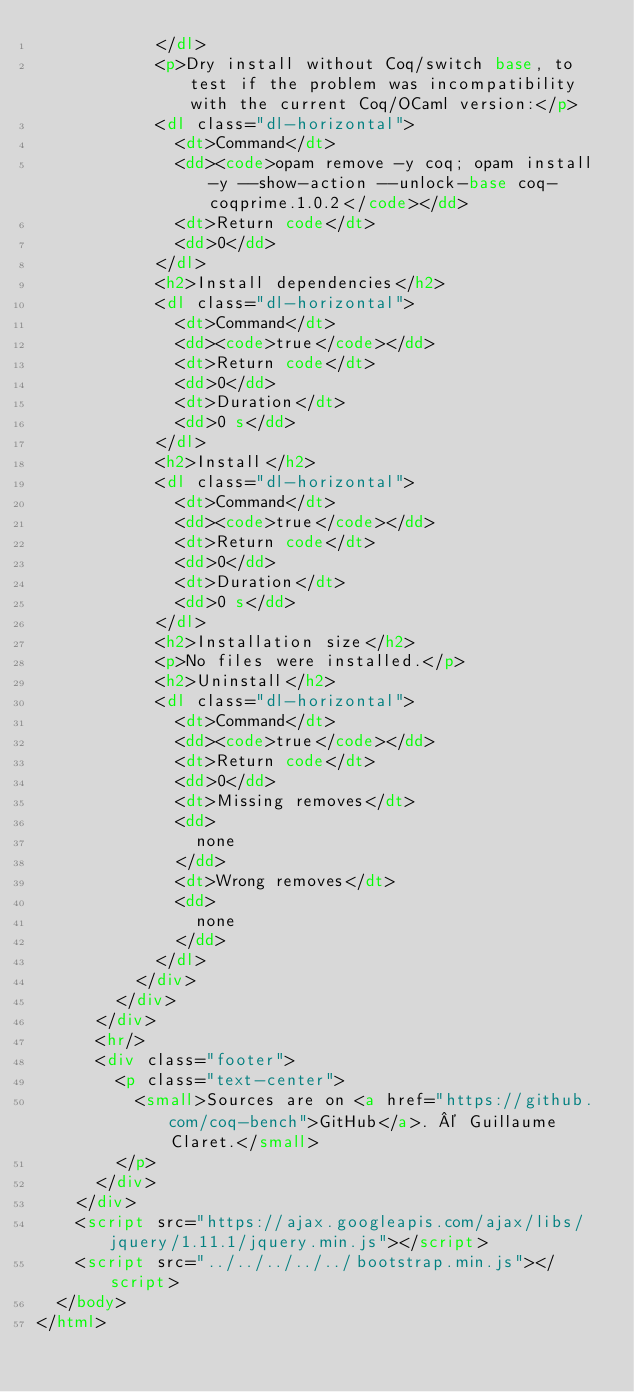Convert code to text. <code><loc_0><loc_0><loc_500><loc_500><_HTML_>            </dl>
            <p>Dry install without Coq/switch base, to test if the problem was incompatibility with the current Coq/OCaml version:</p>
            <dl class="dl-horizontal">
              <dt>Command</dt>
              <dd><code>opam remove -y coq; opam install -y --show-action --unlock-base coq-coqprime.1.0.2</code></dd>
              <dt>Return code</dt>
              <dd>0</dd>
            </dl>
            <h2>Install dependencies</h2>
            <dl class="dl-horizontal">
              <dt>Command</dt>
              <dd><code>true</code></dd>
              <dt>Return code</dt>
              <dd>0</dd>
              <dt>Duration</dt>
              <dd>0 s</dd>
            </dl>
            <h2>Install</h2>
            <dl class="dl-horizontal">
              <dt>Command</dt>
              <dd><code>true</code></dd>
              <dt>Return code</dt>
              <dd>0</dd>
              <dt>Duration</dt>
              <dd>0 s</dd>
            </dl>
            <h2>Installation size</h2>
            <p>No files were installed.</p>
            <h2>Uninstall</h2>
            <dl class="dl-horizontal">
              <dt>Command</dt>
              <dd><code>true</code></dd>
              <dt>Return code</dt>
              <dd>0</dd>
              <dt>Missing removes</dt>
              <dd>
                none
              </dd>
              <dt>Wrong removes</dt>
              <dd>
                none
              </dd>
            </dl>
          </div>
        </div>
      </div>
      <hr/>
      <div class="footer">
        <p class="text-center">
          <small>Sources are on <a href="https://github.com/coq-bench">GitHub</a>. © Guillaume Claret.</small>
        </p>
      </div>
    </div>
    <script src="https://ajax.googleapis.com/ajax/libs/jquery/1.11.1/jquery.min.js"></script>
    <script src="../../../../../bootstrap.min.js"></script>
  </body>
</html>
</code> 